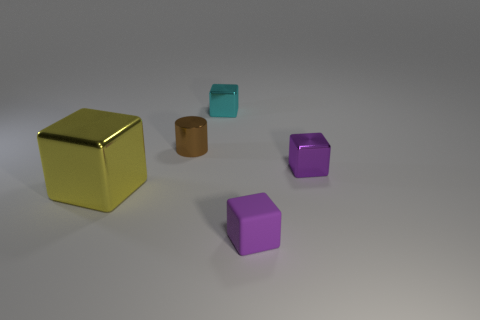Subtract all purple rubber cubes. How many cubes are left? 3 Subtract all yellow balls. How many purple blocks are left? 2 Subtract all cyan blocks. How many blocks are left? 3 Add 1 large red metal cylinders. How many objects exist? 6 Add 4 big cyan metallic blocks. How many big cyan metallic blocks exist? 4 Subtract 0 brown spheres. How many objects are left? 5 Subtract all cubes. How many objects are left? 1 Subtract 3 blocks. How many blocks are left? 1 Subtract all green blocks. Subtract all brown cylinders. How many blocks are left? 4 Subtract all red shiny objects. Subtract all cyan metallic blocks. How many objects are left? 4 